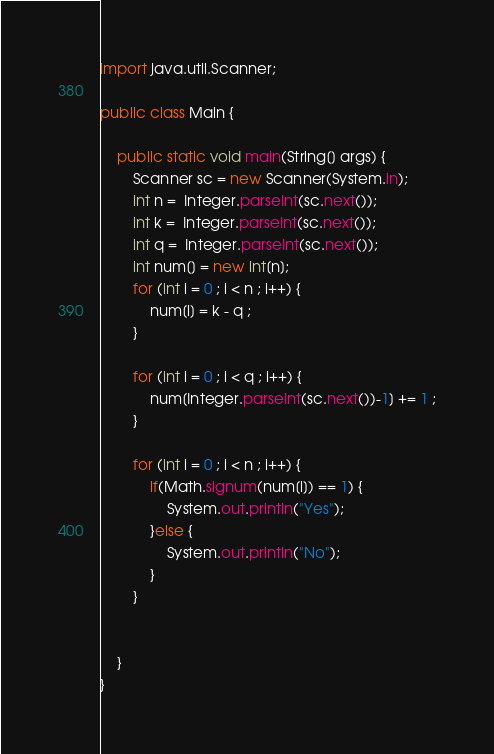<code> <loc_0><loc_0><loc_500><loc_500><_Java_>import java.util.Scanner;

public class Main {

	public static void main(String[] args) {
		Scanner sc = new Scanner(System.in);
		int n =  Integer.parseInt(sc.next());
		int k =  Integer.parseInt(sc.next());
		int q =  Integer.parseInt(sc.next());
		int num[] = new int[n];
		for (int i = 0 ; i < n ; i++) {
			num[i] = k - q ;
		}
		
		for (int i = 0 ; i < q ; i++) {
			num[Integer.parseInt(sc.next())-1] += 1 ;
		}
		
		for (int i = 0 ; i < n ; i++) {
			if(Math.signum(num[i]) == 1) {
				System.out.println("Yes");
			}else {
				System.out.println("No");
			}
		}
		
		
	}	
}</code> 